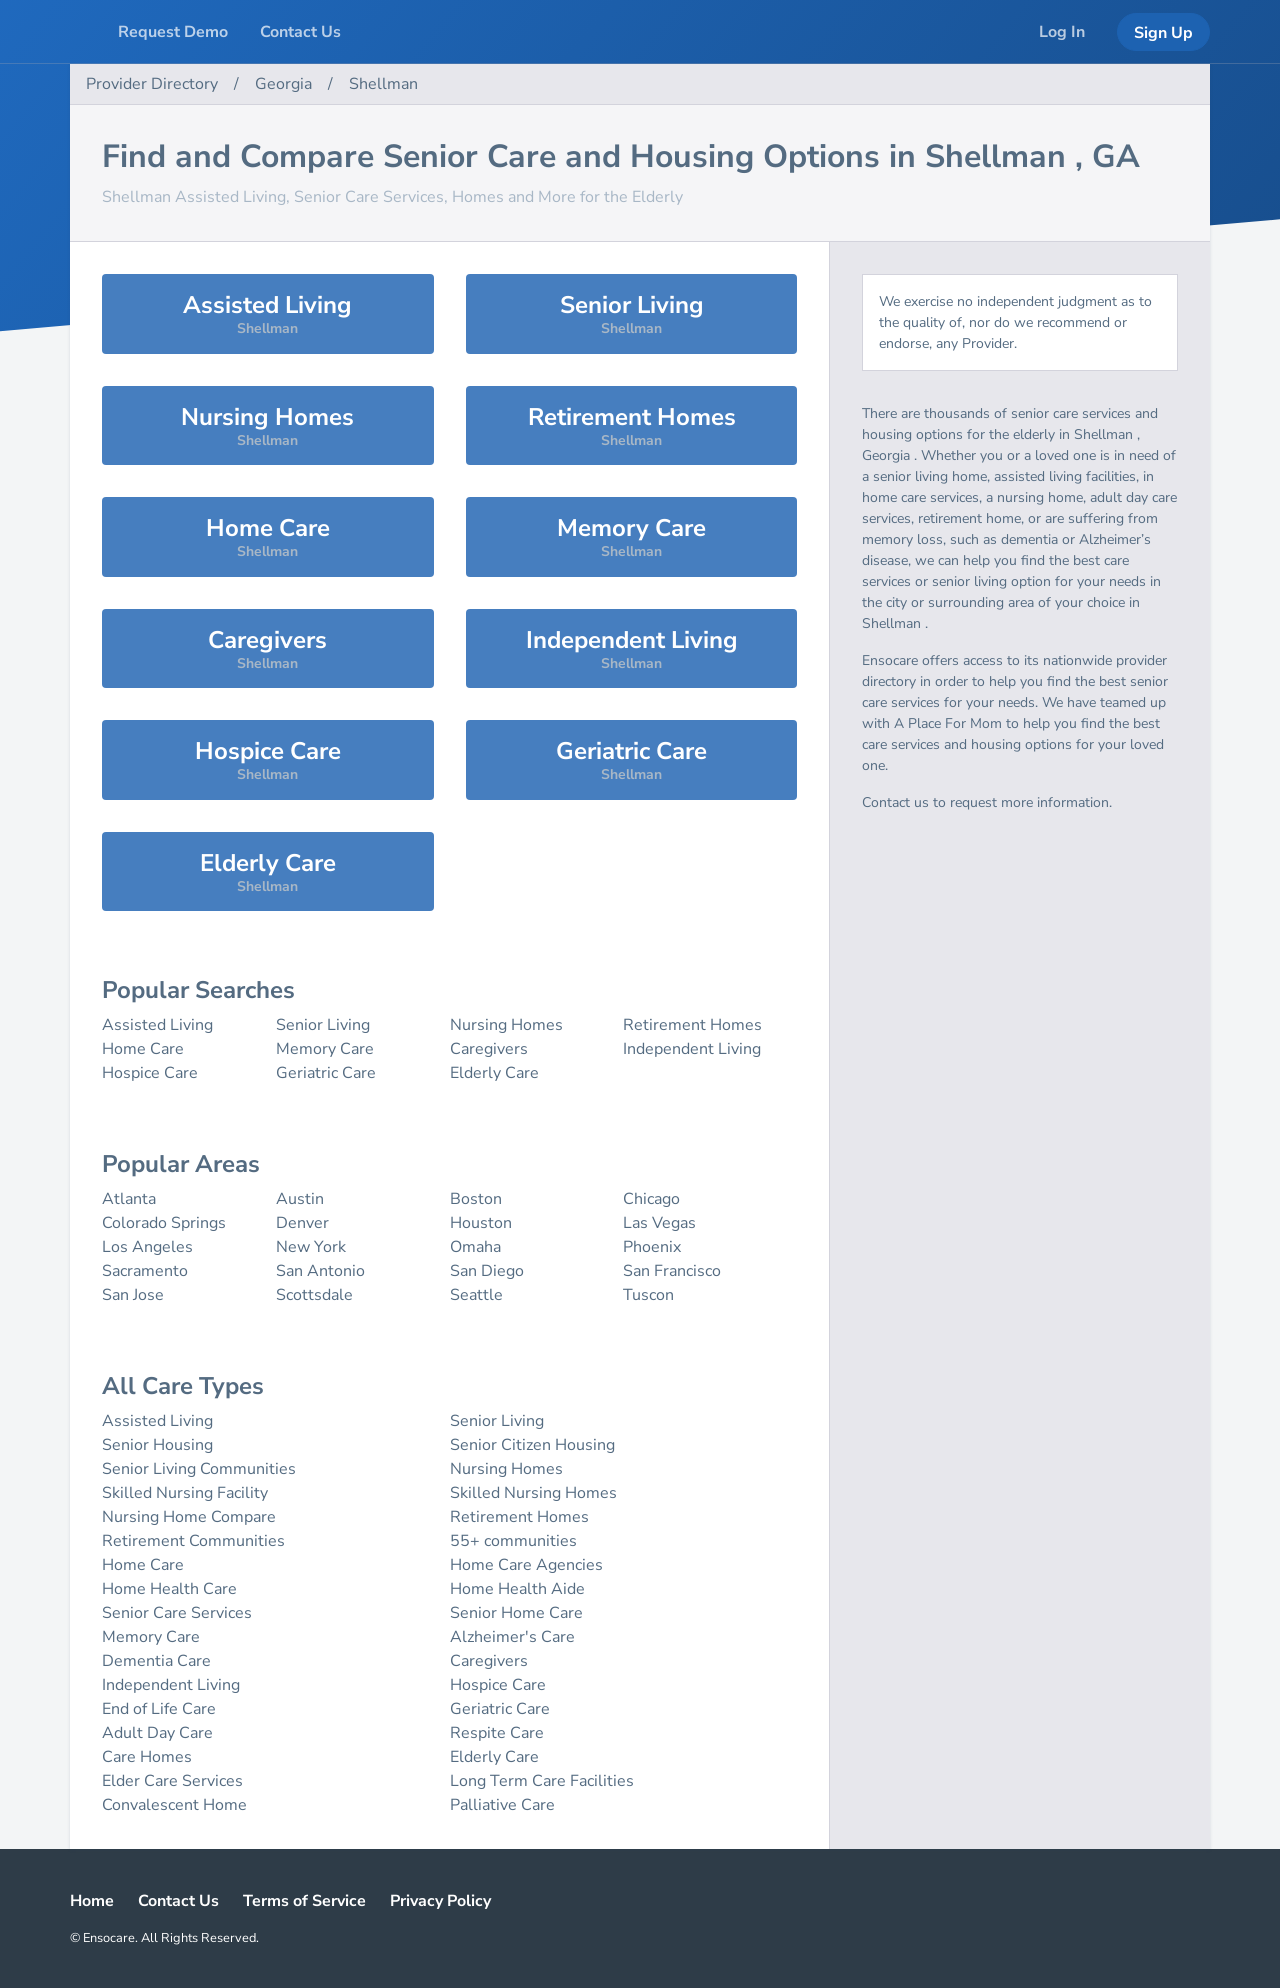What are the options available for 'Home Care' as represented in the image? Within the 'Home Care' category presented on the website, services include standard home care, home health care which includes medical supervision, and also home health aides who assist with daily living activities. These services are designed to enable seniors to continue living in their own homes while receiving the care they require. 